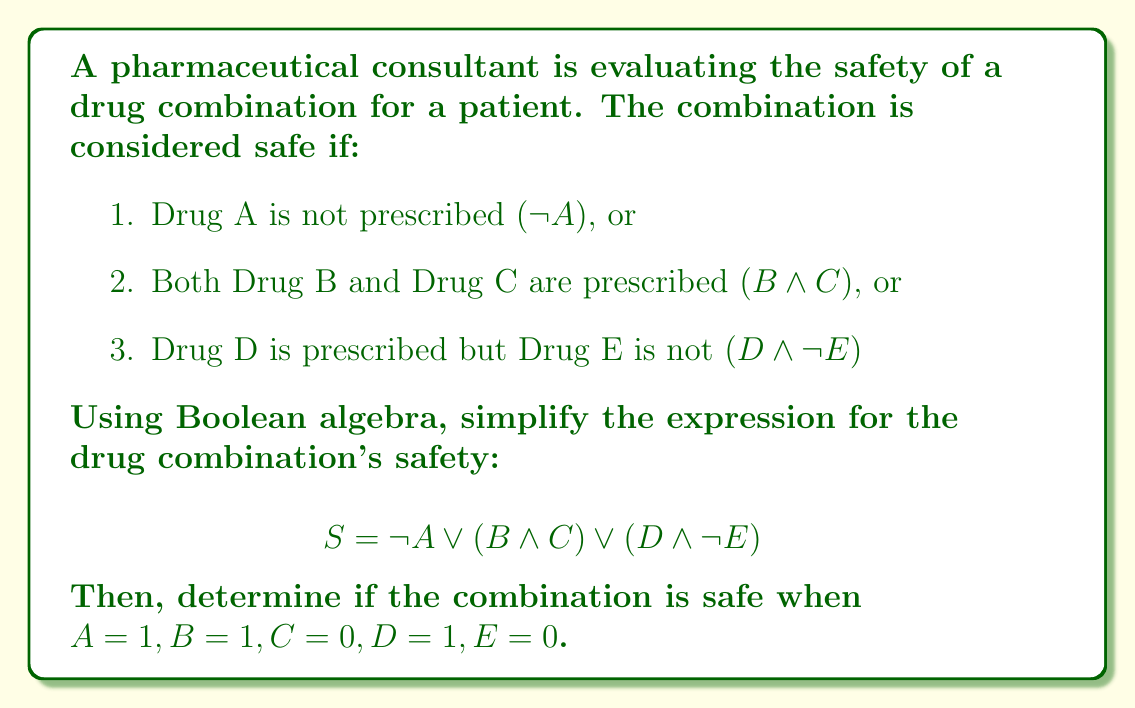Can you solve this math problem? 1. The given expression for safety (S) is:
   $S = \neg A \vee (B \wedge C) \vee (D \wedge \neg E)$

2. This expression is already in disjunctive normal form (DNF), so no further simplification is needed.

3. To determine if the combination is safe, we need to evaluate the expression with the given values:
   $A = 1, B = 1, C = 0, D = 1, E = 0$

4. Let's evaluate each term:
   a. $\neg A = \neg 1 = 0$
   b. $B \wedge C = 1 \wedge 0 = 0$
   c. $D \wedge \neg E = 1 \wedge \neg 0 = 1 \wedge 1 = 1$

5. Now, we can substitute these values into the original expression:
   $S = 0 \vee 0 \vee 1$

6. Using the OR operation:
   $S = 1$

7. Since the result is 1 (true), the drug combination is safe under these conditions.
Answer: $S = 1$ (Safe) 